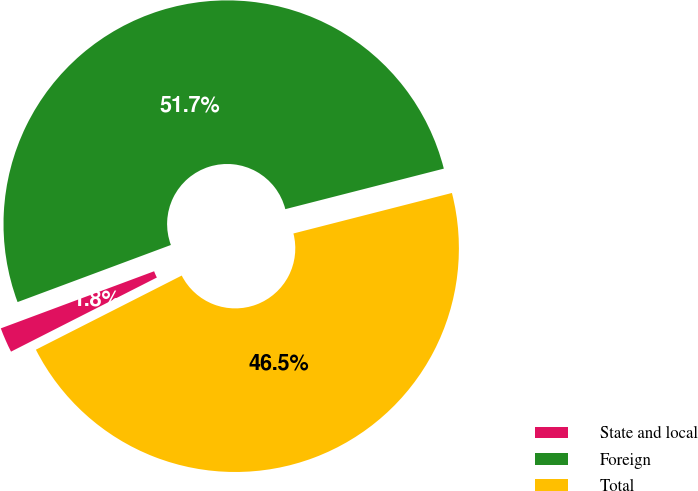Convert chart to OTSL. <chart><loc_0><loc_0><loc_500><loc_500><pie_chart><fcel>State and local<fcel>Foreign<fcel>Total<nl><fcel>1.81%<fcel>51.69%<fcel>46.5%<nl></chart> 